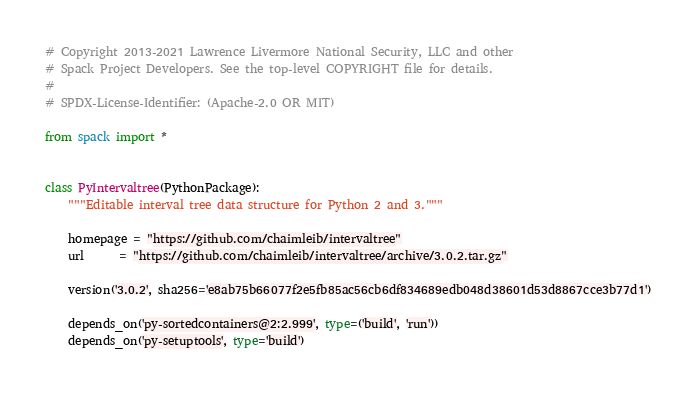<code> <loc_0><loc_0><loc_500><loc_500><_Python_># Copyright 2013-2021 Lawrence Livermore National Security, LLC and other
# Spack Project Developers. See the top-level COPYRIGHT file for details.
#
# SPDX-License-Identifier: (Apache-2.0 OR MIT)

from spack import *


class PyIntervaltree(PythonPackage):
    """Editable interval tree data structure for Python 2 and 3."""

    homepage = "https://github.com/chaimleib/intervaltree"
    url      = "https://github.com/chaimleib/intervaltree/archive/3.0.2.tar.gz"

    version('3.0.2', sha256='e8ab75b66077f2e5fb85ac56cb6df834689edb048d38601d53d8867cce3b77d1')

    depends_on('py-sortedcontainers@2:2.999', type=('build', 'run'))
    depends_on('py-setuptools', type='build')
</code> 